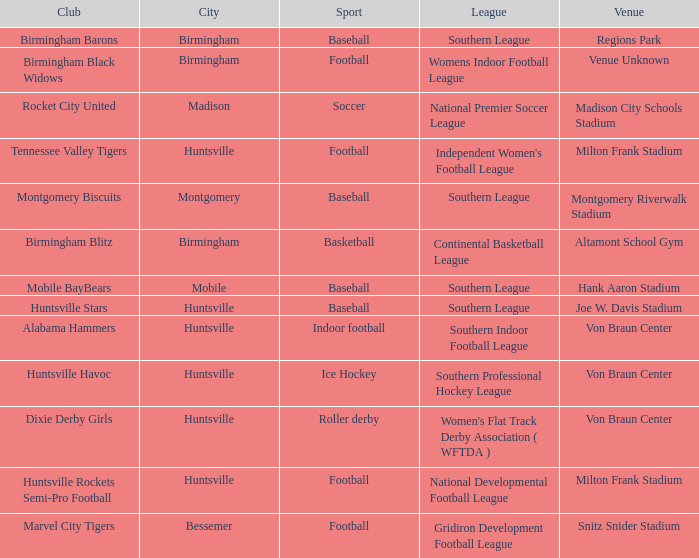Which venue held a basketball team? Altamont School Gym. 